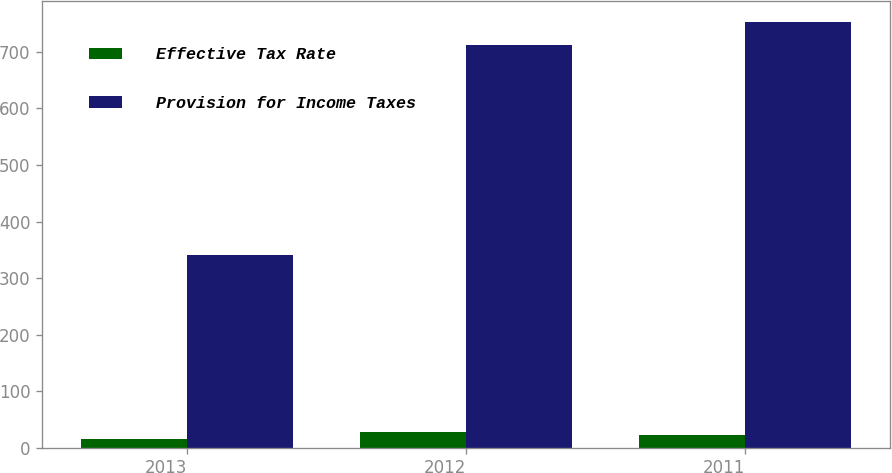Convert chart. <chart><loc_0><loc_0><loc_500><loc_500><stacked_bar_chart><ecel><fcel>2013<fcel>2012<fcel>2011<nl><fcel>Effective Tax Rate<fcel>15.4<fcel>27.1<fcel>23<nl><fcel>Provision for Income Taxes<fcel>341<fcel>711.4<fcel>752.8<nl></chart> 